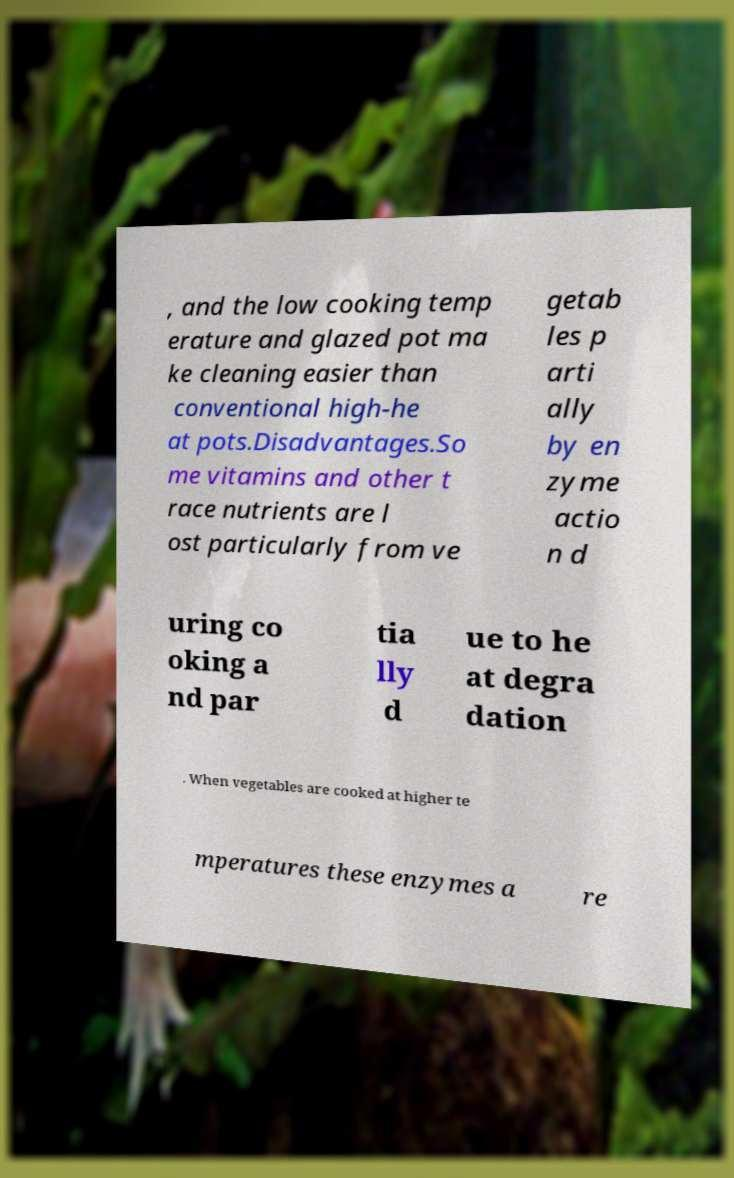Please identify and transcribe the text found in this image. , and the low cooking temp erature and glazed pot ma ke cleaning easier than conventional high-he at pots.Disadvantages.So me vitamins and other t race nutrients are l ost particularly from ve getab les p arti ally by en zyme actio n d uring co oking a nd par tia lly d ue to he at degra dation . When vegetables are cooked at higher te mperatures these enzymes a re 